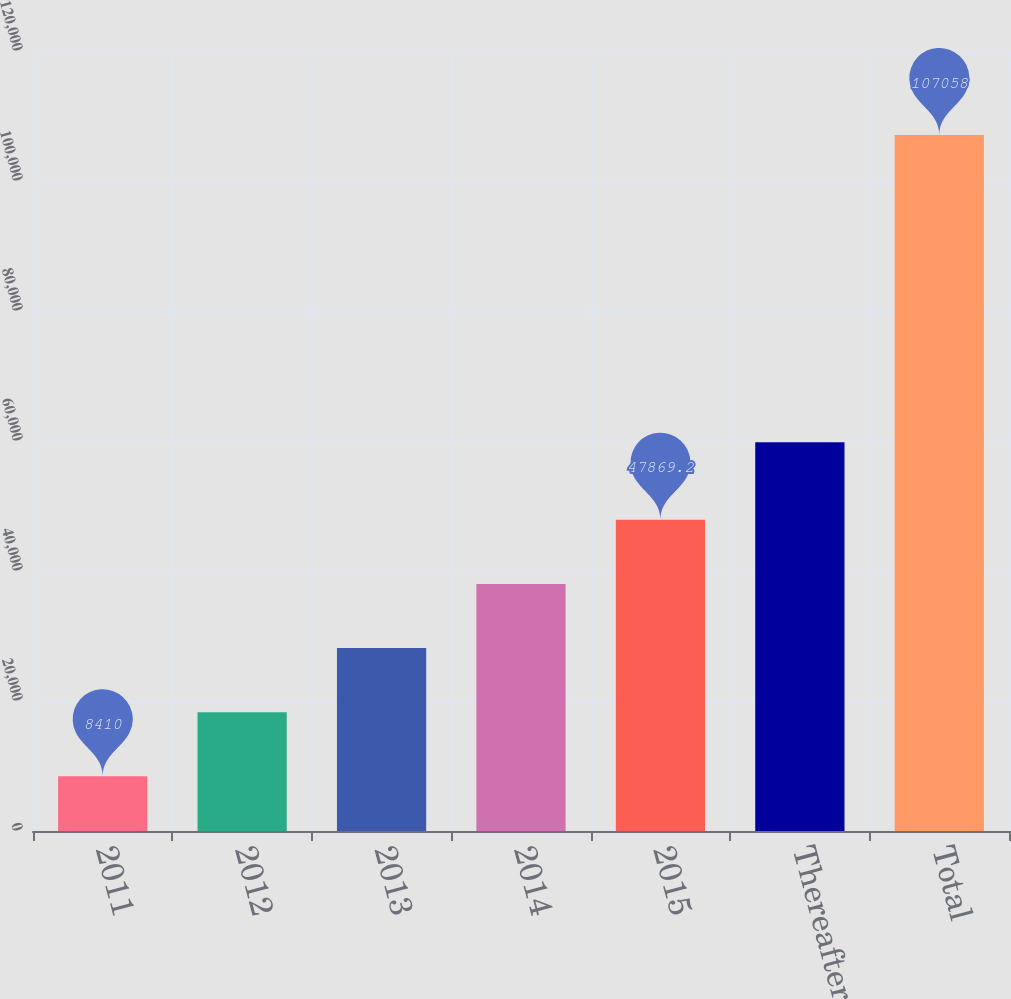Convert chart. <chart><loc_0><loc_0><loc_500><loc_500><bar_chart><fcel>2011<fcel>2012<fcel>2013<fcel>2014<fcel>2015<fcel>Thereafter<fcel>Total<nl><fcel>8410<fcel>18274.8<fcel>28139.6<fcel>38004.4<fcel>47869.2<fcel>59818<fcel>107058<nl></chart> 